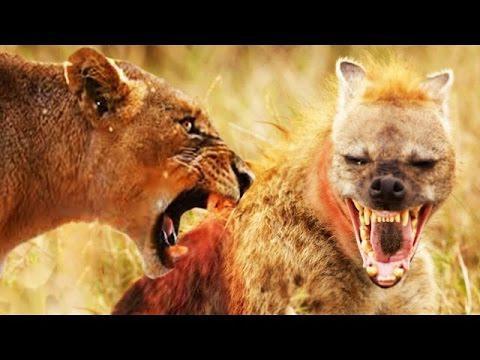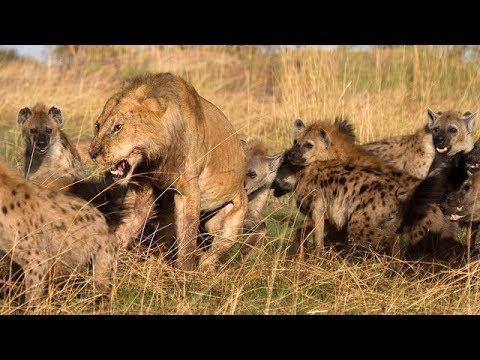The first image is the image on the left, the second image is the image on the right. Assess this claim about the two images: "There is a species other than a hyena in at least one of the images.". Correct or not? Answer yes or no. Yes. 